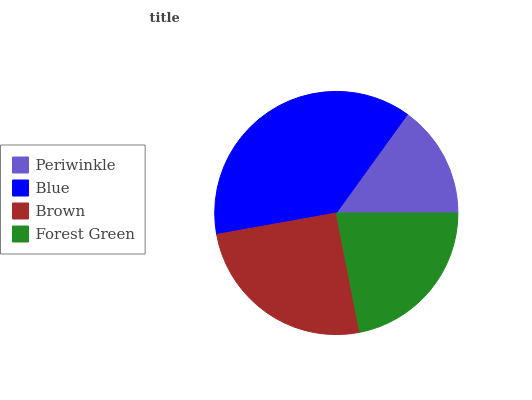Is Periwinkle the minimum?
Answer yes or no. Yes. Is Blue the maximum?
Answer yes or no. Yes. Is Brown the minimum?
Answer yes or no. No. Is Brown the maximum?
Answer yes or no. No. Is Blue greater than Brown?
Answer yes or no. Yes. Is Brown less than Blue?
Answer yes or no. Yes. Is Brown greater than Blue?
Answer yes or no. No. Is Blue less than Brown?
Answer yes or no. No. Is Brown the high median?
Answer yes or no. Yes. Is Forest Green the low median?
Answer yes or no. Yes. Is Forest Green the high median?
Answer yes or no. No. Is Periwinkle the low median?
Answer yes or no. No. 